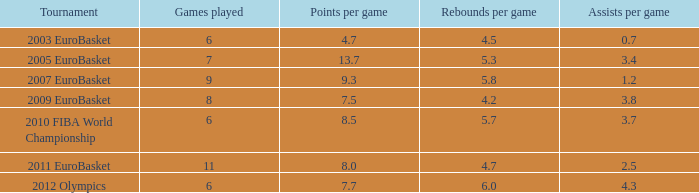2 rebounds per match? 3.8. 